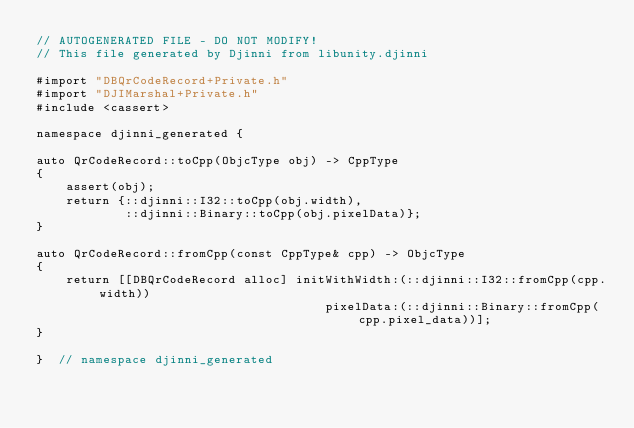Convert code to text. <code><loc_0><loc_0><loc_500><loc_500><_ObjectiveC_>// AUTOGENERATED FILE - DO NOT MODIFY!
// This file generated by Djinni from libunity.djinni

#import "DBQrCodeRecord+Private.h"
#import "DJIMarshal+Private.h"
#include <cassert>

namespace djinni_generated {

auto QrCodeRecord::toCpp(ObjcType obj) -> CppType
{
    assert(obj);
    return {::djinni::I32::toCpp(obj.width),
            ::djinni::Binary::toCpp(obj.pixelData)};
}

auto QrCodeRecord::fromCpp(const CppType& cpp) -> ObjcType
{
    return [[DBQrCodeRecord alloc] initWithWidth:(::djinni::I32::fromCpp(cpp.width))
                                       pixelData:(::djinni::Binary::fromCpp(cpp.pixel_data))];
}

}  // namespace djinni_generated
</code> 